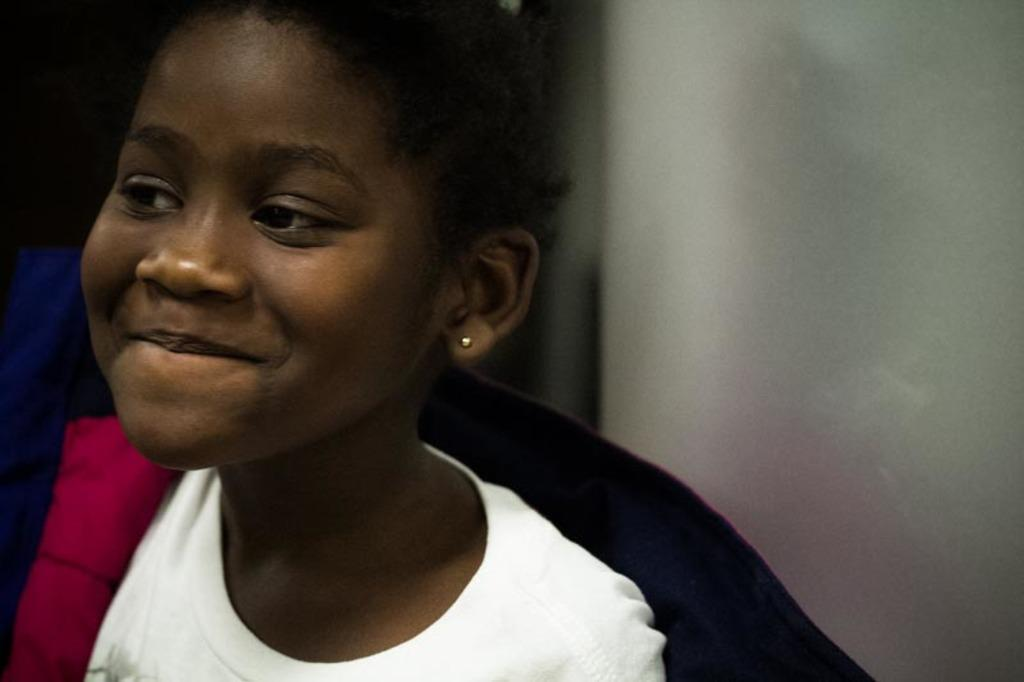What is the main subject of the image? There is a child in the image. What can be observed about the child's appearance? The child is wearing clothes and ear studs. What is the child's facial expression? The child is smiling. How would you describe the background of the image? The background of the image is blurred. How many firemen are present in the image? There are no firemen present in the image; it features a child. What type of addition problem can be solved using the child's ear studs? There is no addition problem related to the child's ear studs in the image. 